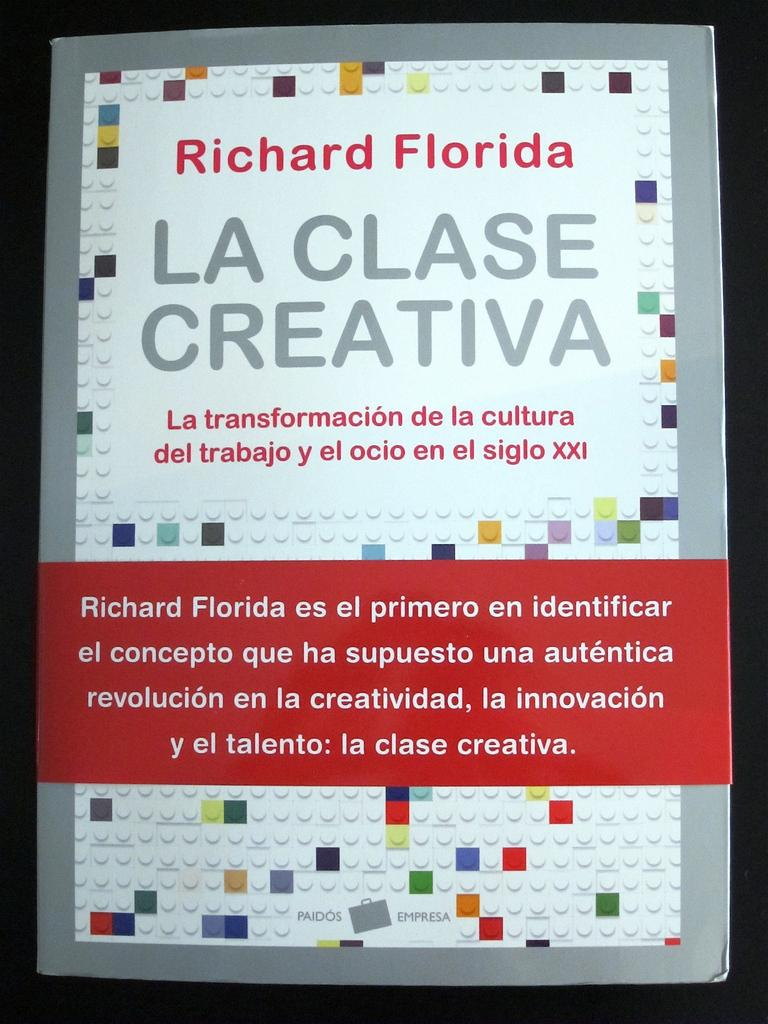<image>
Render a clear and concise summary of the photo. A notice about Richard Florida is written in Spanish. 